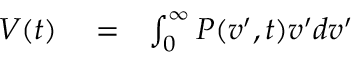<formula> <loc_0><loc_0><loc_500><loc_500>\begin{array} { r l r } { V ( t ) } & = } & { \int _ { 0 } ^ { \infty } P ( v ^ { \prime } , t ) v ^ { \prime } d v ^ { \prime } } \end{array}</formula> 